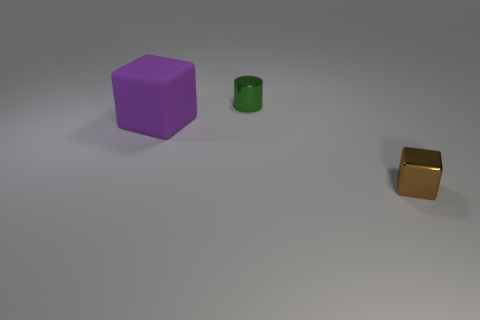Add 1 large metallic spheres. How many objects exist? 4 Add 1 small green things. How many small green things exist? 2 Subtract 0 red spheres. How many objects are left? 3 Subtract all cylinders. How many objects are left? 2 Subtract all brown blocks. Subtract all brown cylinders. How many blocks are left? 1 Subtract all gray cylinders. How many cyan cubes are left? 0 Subtract all spheres. Subtract all green cylinders. How many objects are left? 2 Add 2 tiny green metallic objects. How many tiny green metallic objects are left? 3 